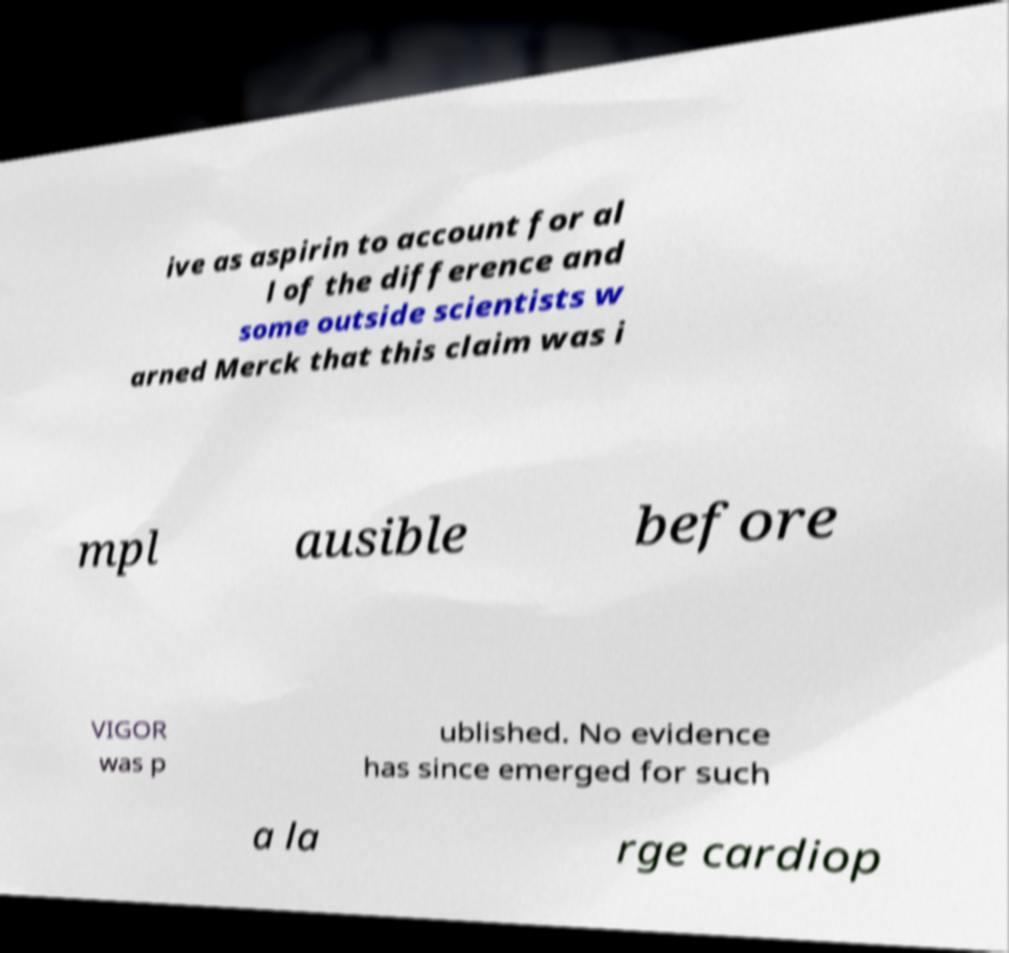Please identify and transcribe the text found in this image. ive as aspirin to account for al l of the difference and some outside scientists w arned Merck that this claim was i mpl ausible before VIGOR was p ublished. No evidence has since emerged for such a la rge cardiop 